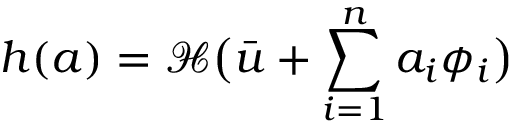<formula> <loc_0><loc_0><loc_500><loc_500>h ( a ) = \mathcal { H } \left ( \bar { u } + \sum _ { i = 1 } ^ { n } a _ { i } \phi _ { i } \right )</formula> 